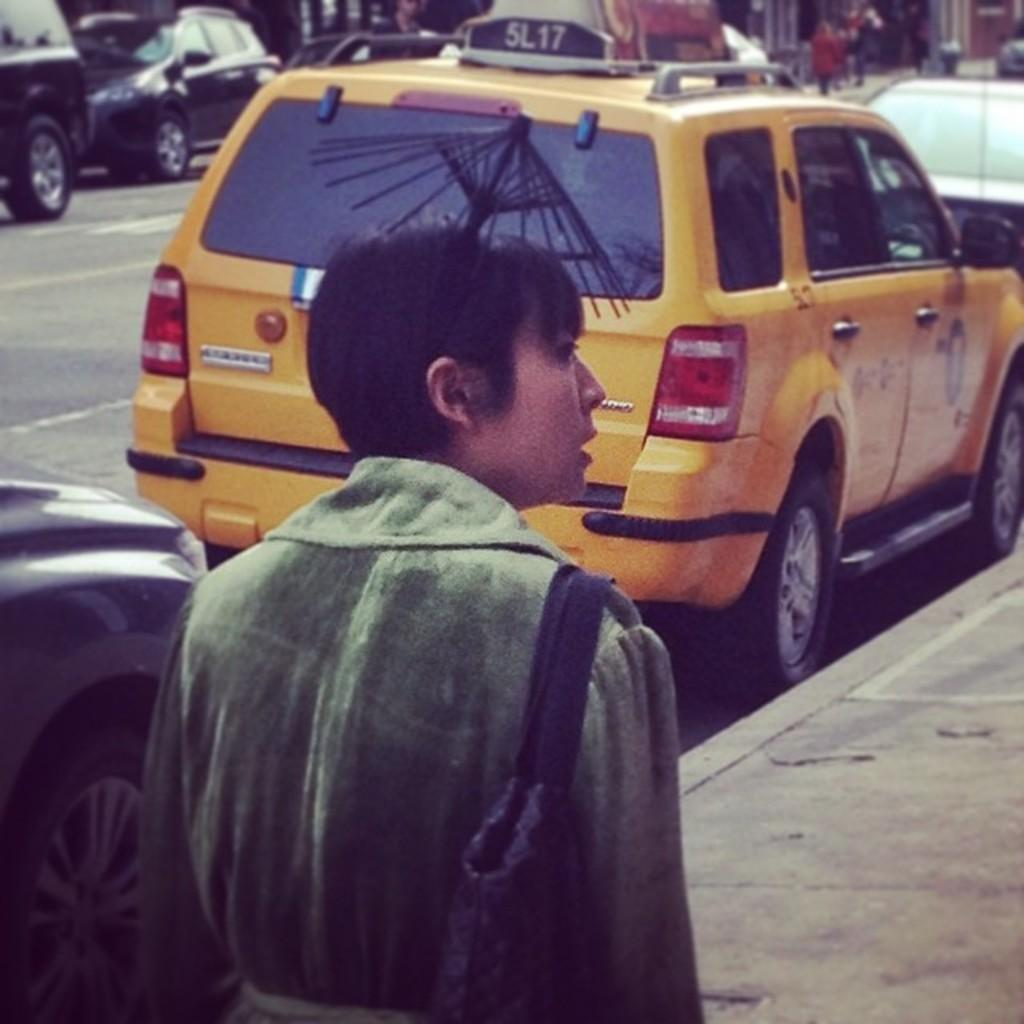<image>
Present a compact description of the photo's key features. A woman stands on the sidewalk next to a cab with the call number 5L17 